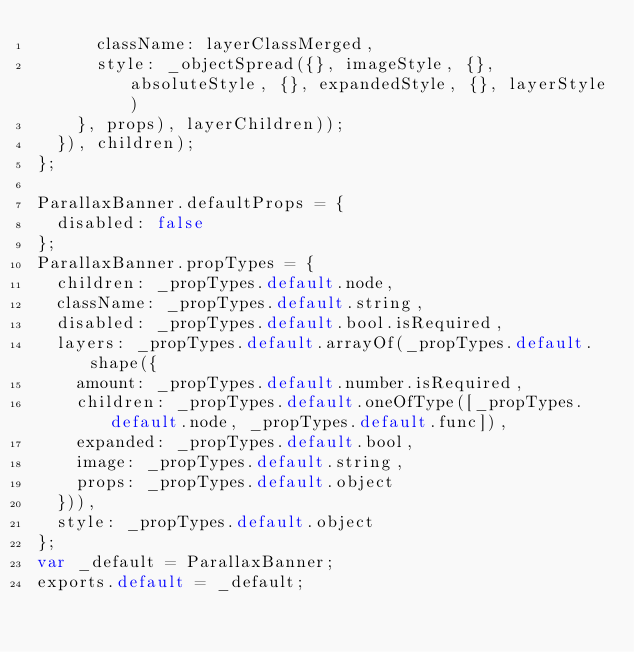Convert code to text. <code><loc_0><loc_0><loc_500><loc_500><_JavaScript_>      className: layerClassMerged,
      style: _objectSpread({}, imageStyle, {}, absoluteStyle, {}, expandedStyle, {}, layerStyle)
    }, props), layerChildren));
  }), children);
};

ParallaxBanner.defaultProps = {
  disabled: false
};
ParallaxBanner.propTypes = {
  children: _propTypes.default.node,
  className: _propTypes.default.string,
  disabled: _propTypes.default.bool.isRequired,
  layers: _propTypes.default.arrayOf(_propTypes.default.shape({
    amount: _propTypes.default.number.isRequired,
    children: _propTypes.default.oneOfType([_propTypes.default.node, _propTypes.default.func]),
    expanded: _propTypes.default.bool,
    image: _propTypes.default.string,
    props: _propTypes.default.object
  })),
  style: _propTypes.default.object
};
var _default = ParallaxBanner;
exports.default = _default;</code> 